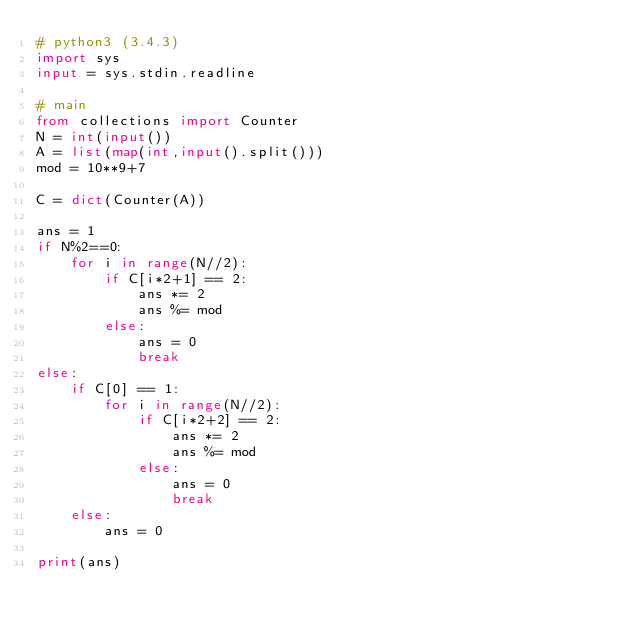Convert code to text. <code><loc_0><loc_0><loc_500><loc_500><_Python_># python3 (3.4.3)
import sys
input = sys.stdin.readline

# main
from collections import Counter
N = int(input())
A = list(map(int,input().split()))
mod = 10**9+7

C = dict(Counter(A))

ans = 1
if N%2==0:
    for i in range(N//2):
        if C[i*2+1] == 2:
            ans *= 2
            ans %= mod
        else:
            ans = 0
            break
else:
    if C[0] == 1:
        for i in range(N//2):
            if C[i*2+2] == 2:
                ans *= 2
                ans %= mod
            else:
                ans = 0
                break
    else:
        ans = 0

print(ans)</code> 